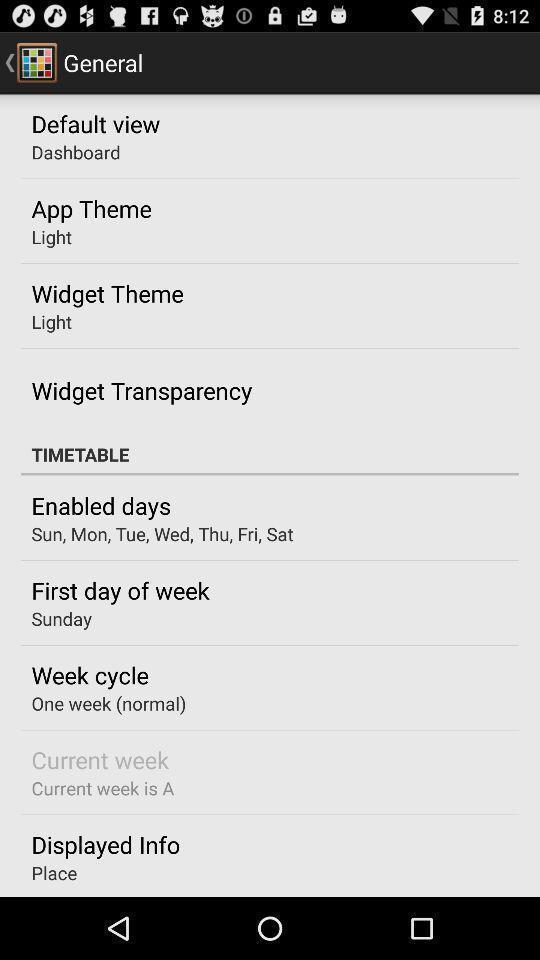What is the overall content of this screenshot? Page displaying general options. 